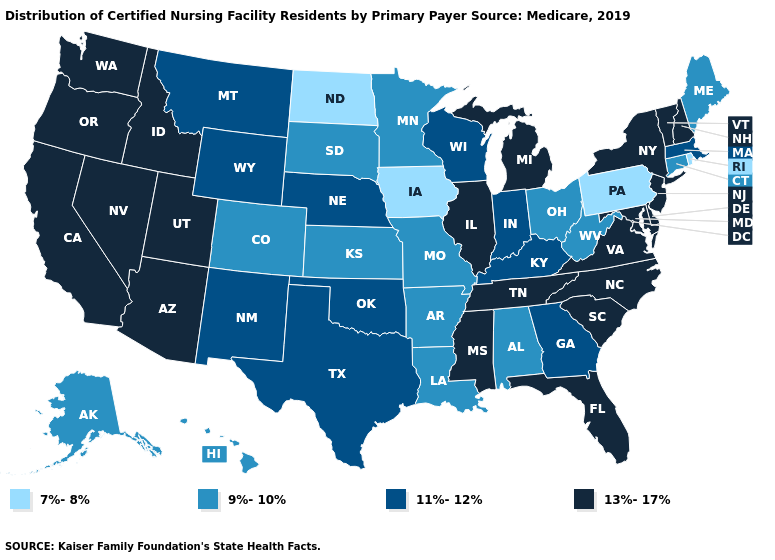Among the states that border California , which have the highest value?
Be succinct. Arizona, Nevada, Oregon. Name the states that have a value in the range 7%-8%?
Write a very short answer. Iowa, North Dakota, Pennsylvania, Rhode Island. What is the value of Kentucky?
Short answer required. 11%-12%. Name the states that have a value in the range 9%-10%?
Be succinct. Alabama, Alaska, Arkansas, Colorado, Connecticut, Hawaii, Kansas, Louisiana, Maine, Minnesota, Missouri, Ohio, South Dakota, West Virginia. What is the value of Georgia?
Keep it brief. 11%-12%. What is the highest value in states that border Connecticut?
Answer briefly. 13%-17%. Does Arkansas have the lowest value in the South?
Short answer required. Yes. Which states have the lowest value in the USA?
Quick response, please. Iowa, North Dakota, Pennsylvania, Rhode Island. What is the highest value in states that border Maine?
Give a very brief answer. 13%-17%. Does Alabama have the lowest value in the South?
Answer briefly. Yes. What is the value of Nevada?
Concise answer only. 13%-17%. What is the highest value in the Northeast ?
Answer briefly. 13%-17%. Name the states that have a value in the range 13%-17%?
Be succinct. Arizona, California, Delaware, Florida, Idaho, Illinois, Maryland, Michigan, Mississippi, Nevada, New Hampshire, New Jersey, New York, North Carolina, Oregon, South Carolina, Tennessee, Utah, Vermont, Virginia, Washington. Does Vermont have the highest value in the USA?
Quick response, please. Yes. What is the lowest value in states that border Missouri?
Answer briefly. 7%-8%. 